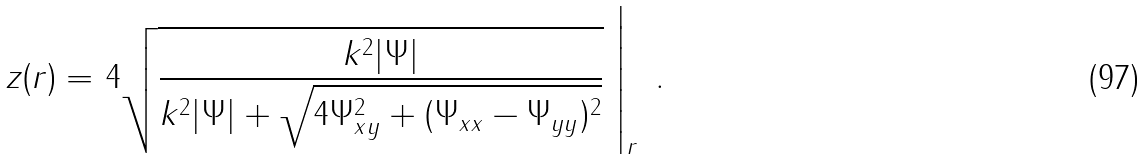<formula> <loc_0><loc_0><loc_500><loc_500>z ( { r } ) = \left . 4 \sqrt { \frac { k ^ { 2 } | \Psi | } { k ^ { 2 } | \Psi | + \sqrt { 4 \Psi _ { x y } ^ { 2 } + ( \Psi _ { x x } - \Psi _ { y y } ) ^ { 2 } } } } \ \right | _ { r } \ .</formula> 